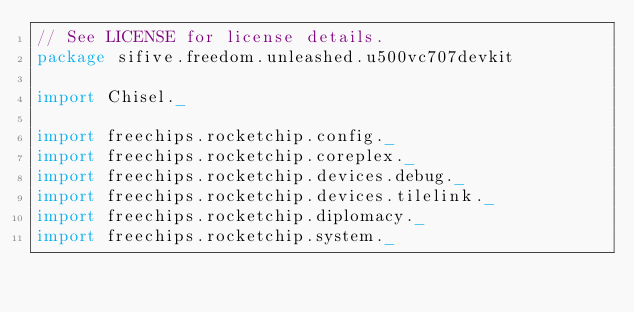Convert code to text. <code><loc_0><loc_0><loc_500><loc_500><_Scala_>// See LICENSE for license details.
package sifive.freedom.unleashed.u500vc707devkit

import Chisel._

import freechips.rocketchip.config._
import freechips.rocketchip.coreplex._
import freechips.rocketchip.devices.debug._
import freechips.rocketchip.devices.tilelink._
import freechips.rocketchip.diplomacy._
import freechips.rocketchip.system._
</code> 